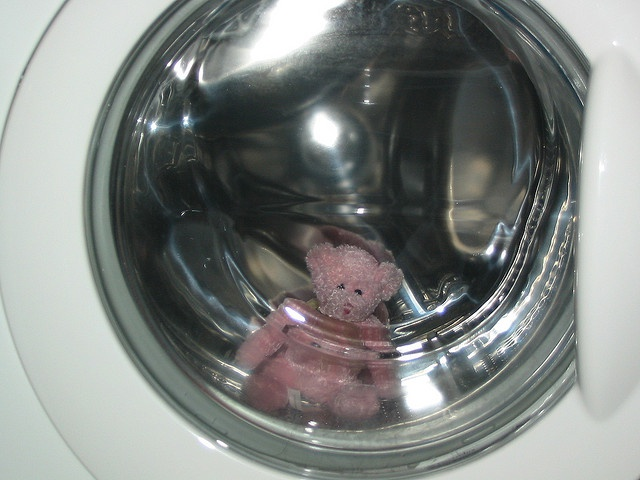Describe the objects in this image and their specific colors. I can see a teddy bear in lightgray and gray tones in this image. 